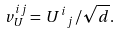<formula> <loc_0><loc_0><loc_500><loc_500>v _ { U } ^ { i j } = \, { U ^ { i } } _ { j } \, / \sqrt { d } .</formula> 